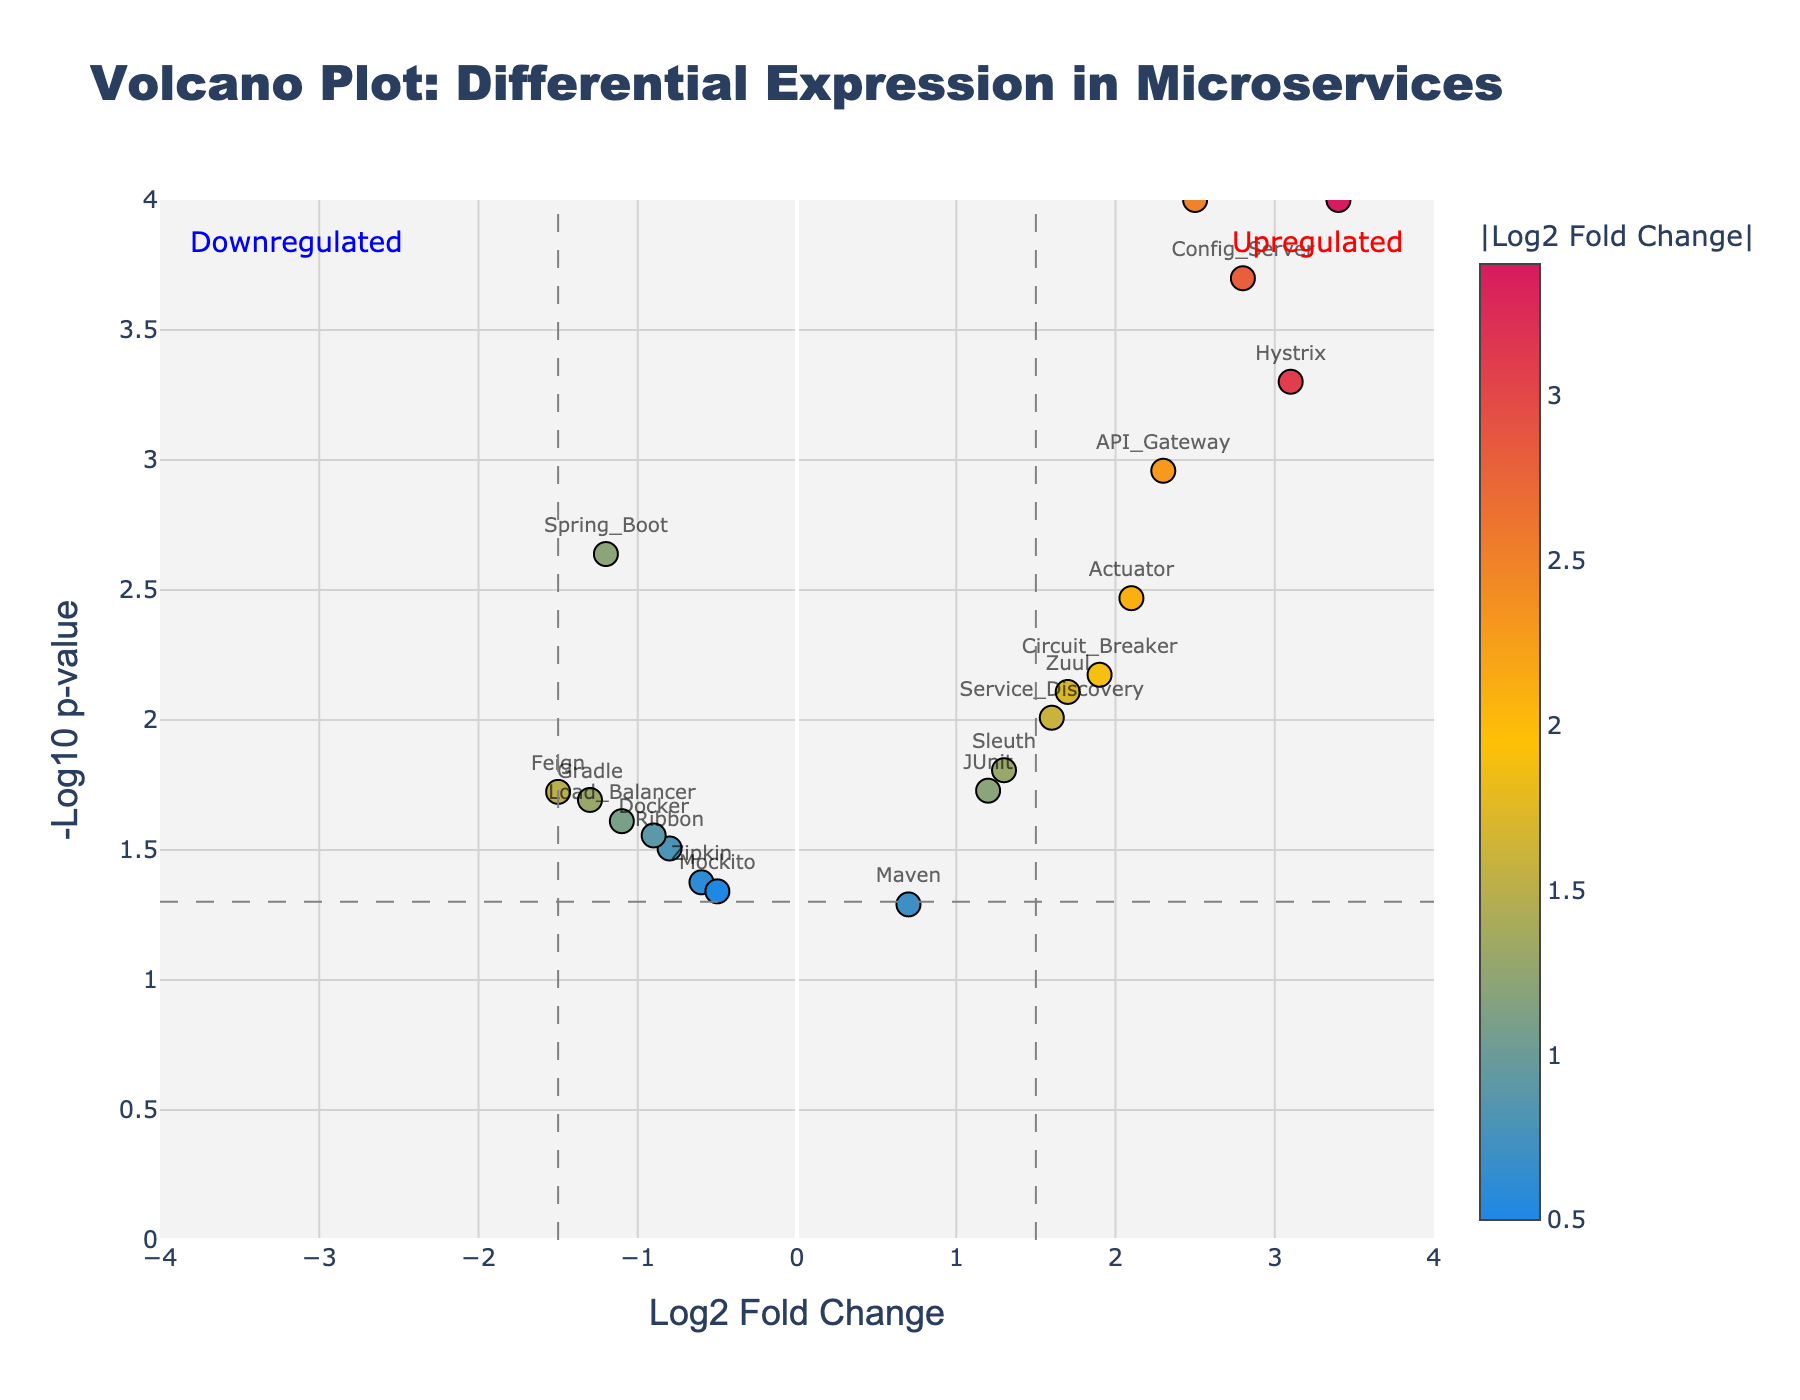What is the title of the plot? The title is displayed at the top of the plot and reads "Volcano Plot: Differential Expression in Microservices."
Answer: Volcano Plot: Differential Expression in Microservices Which gene has the highest log2 fold change? By looking at the x-axis, the gene with the highest log2 fold change value is at the farthest right point. The corresponding label for this point is "Kubernetes."
Answer: Kubernetes Which gene has the smallest p-value? The y-axis represents -log10(p-value), so the highest point on this axis has the smallest p-value. The label next to this highest point is "Eureka."
Answer: Eureka How many genes are downregulated (log2 fold change < -1.5)? By identifying which points fall left of the -1.5 threshold line on the x-axis, there is only one point labeled "Feign" that fits this condition.
Answer: 1 Which genes are upregulated with a p-value less than 0.01? Upregulated genes have a positive log2 fold change, and p-values less than 0.01 mean points above the corresponding horizontal threshold on the y-axis. Points labeled "Eureka," "Hystrix," "Config_Server," "Actuator," "API_Gateway," and "Kubernetes" fit these criteria.
Answer: Eureka, Hystrix, Config_Server, Actuator, API_Gateway, Kubernetes Compare the -log10(p-value) for Hystrix and Config_Server. Which one is higher? Look at the y-axis values for both genes. The y-axis value representing -log10(p-value) for Config_Server is higher than for Hystrix.
Answer: Config_Server What are the log2 fold change and p-value for the gene "Zuul"? Hover over or look closely at the "Zuul" point to see its details: log2 fold change is 1.7 and p-value is 0.0078.
Answer: Log2 fold change: 1.7, p-value: 0.0078 Is the gene "Gradle" statistically significant, considering the p-value threshold (0.05)? Check if the point labeled "Gradle" is above the horizontal threshold line representing p = 0.05 on the y-axis. It is, so the gene is statistically significant.
Answer: Yes Find the average log2 fold change of genes with p-values less than 0.01. Filter genes with p-values less than 0.01: Eureka (2.5), Hystrix (3.1), Config_Server (2.8), Actuator (2.1), API_Gateway (2.3), Kubernetes (3.4). Calculate the average log2 fold change: (2.5 + 3.1 + 2.8 + 2.1 + 2.3 + 3.4) / 6 = 2.70.
Answer: 2.70 